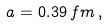Convert formula to latex. <formula><loc_0><loc_0><loc_500><loc_500>a = 0 . 3 9 \, f m \, ,</formula> 